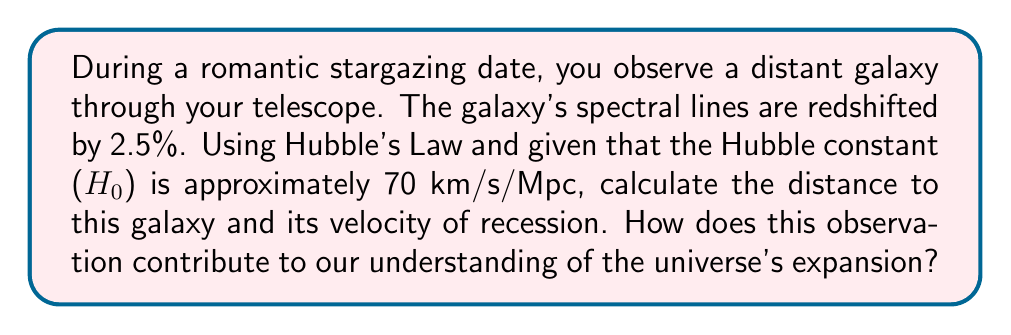Provide a solution to this math problem. To solve this problem, we'll use Hubble's Law and the redshift formula. Let's break it down step-by-step:

1. Redshift calculation:
The redshift (z) is given as 2.5% or 0.025.

2. Velocity calculation using the redshift formula:
The velocity of recession (v) is related to the redshift by:
$$ v = c \cdot z $$
where c is the speed of light (approximately 3 × 10⁸ m/s).

$$ v = (3 \times 10^8 \text{ m/s}) \cdot 0.025 = 7.5 \times 10^6 \text{ m/s} $$

Converting to km/s:
$$ v = 7,500 \text{ km/s} $$

3. Distance calculation using Hubble's Law:
Hubble's Law states that:
$$ v = H_0 \cdot d $$
where v is the velocity of recession, H₀ is the Hubble constant, and d is the distance.

Rearranging the equation to solve for d:
$$ d = \frac{v}{H_0} $$

Substituting the values:
$$ d = \frac{7,500 \text{ km/s}}{70 \text{ km/s/Mpc}} = 107.14 \text{ Mpc} $$

4. Understanding the universe's expansion:
This observation contributes to our understanding of the universe's expansion by providing empirical evidence for Hubble's Law. The redshift indicates that the galaxy is moving away from us, and the calculated velocity and distance demonstrate the linear relationship between a galaxy's distance and its recession velocity. This supports the concept of an expanding universe, where more distant objects are receding faster than closer ones.
Answer: The galaxy is approximately 107.14 Mpc away and is receding at a velocity of 7,500 km/s. This observation supports the concept of an expanding universe by demonstrating the linear relationship between distance and recession velocity as described by Hubble's Law. 